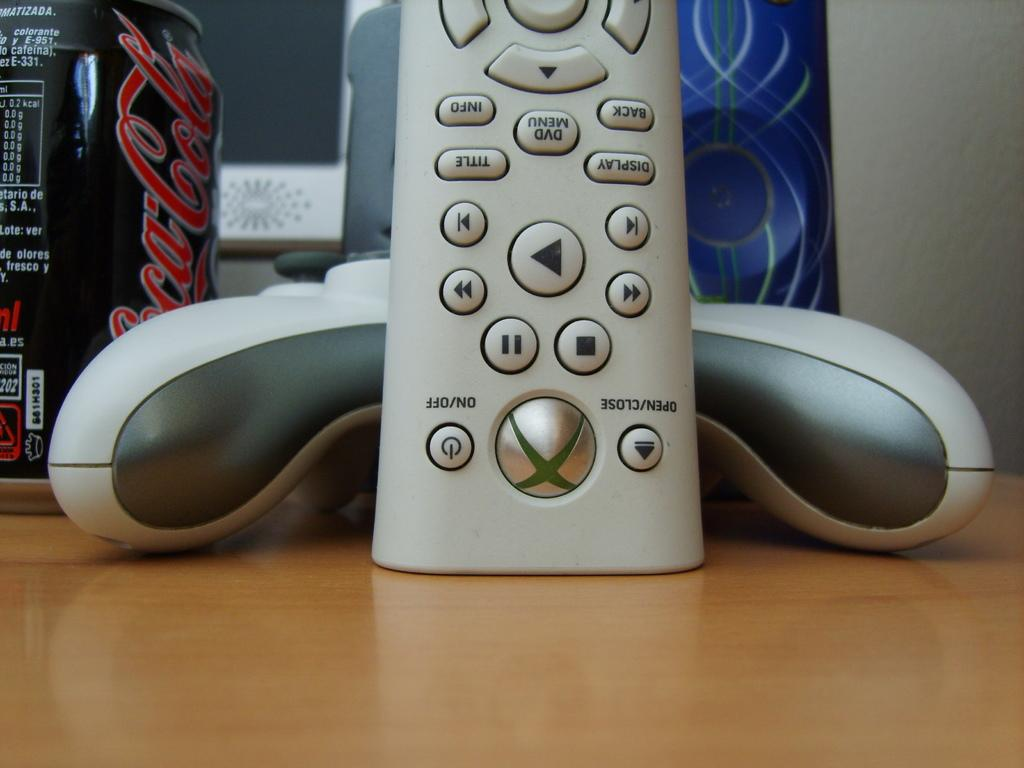Provide a one-sentence caption for the provided image. An Xbox 360 remote, controller and a Coca-Cola can are sitting on a wooden desk. 